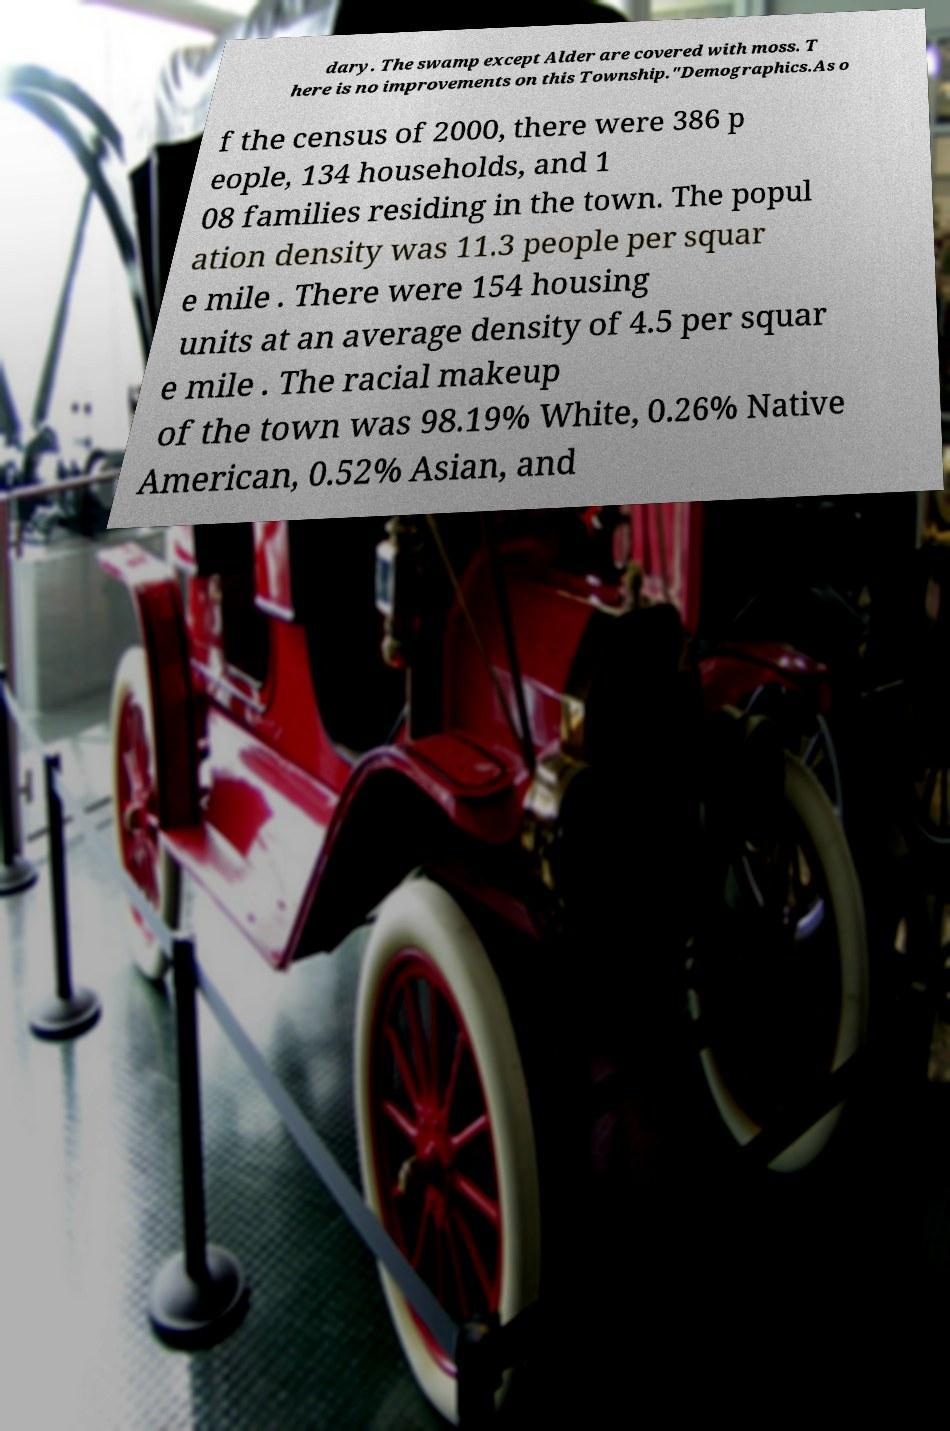Could you extract and type out the text from this image? dary. The swamp except Alder are covered with moss. T here is no improvements on this Township."Demographics.As o f the census of 2000, there were 386 p eople, 134 households, and 1 08 families residing in the town. The popul ation density was 11.3 people per squar e mile . There were 154 housing units at an average density of 4.5 per squar e mile . The racial makeup of the town was 98.19% White, 0.26% Native American, 0.52% Asian, and 